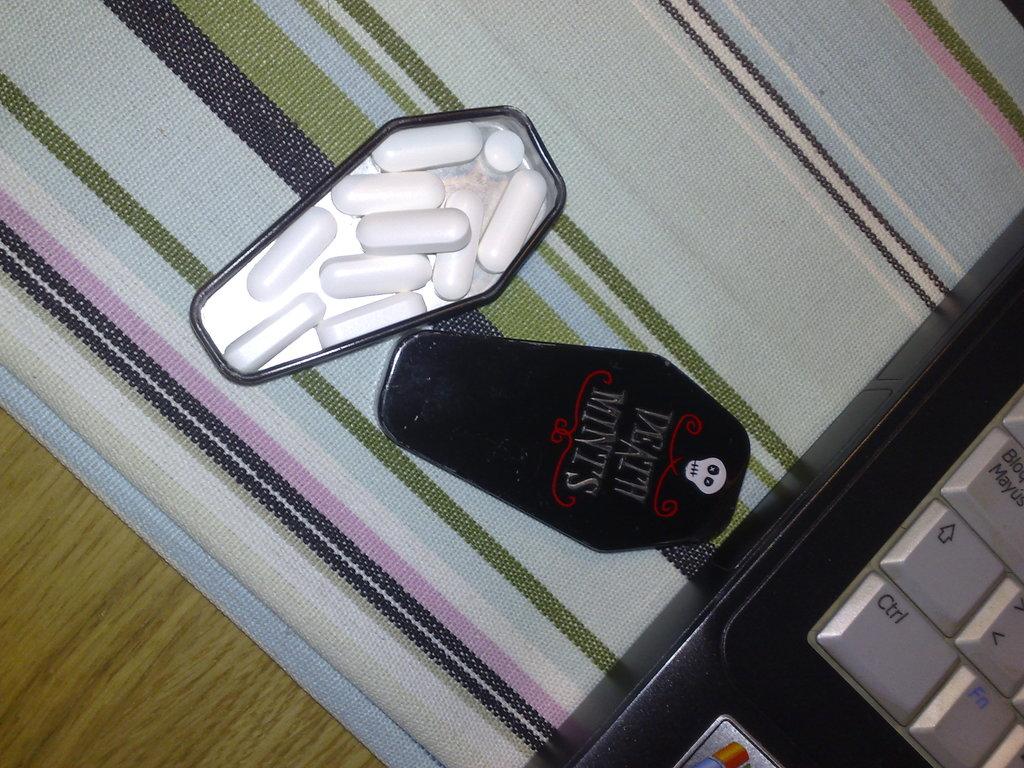What type of mints are these?
Ensure brevity in your answer.  Death mints. 